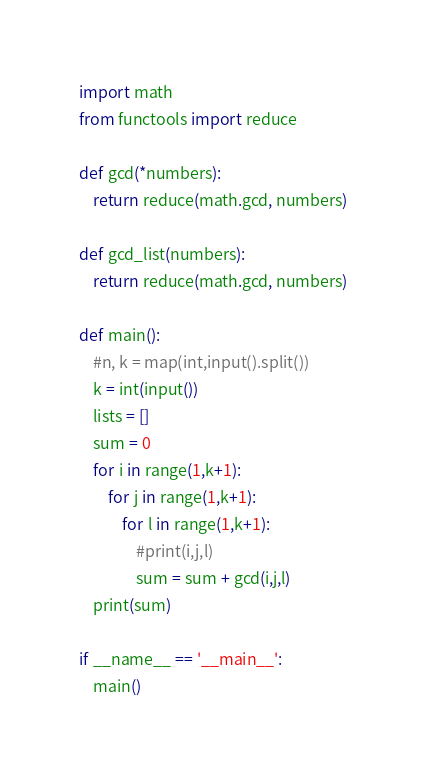<code> <loc_0><loc_0><loc_500><loc_500><_Python_>import math
from functools import reduce

def gcd(*numbers):
    return reduce(math.gcd, numbers)
  
def gcd_list(numbers):
    return reduce(math.gcd, numbers)

def main():
    #n, k = map(int,input().split())
    k = int(input())
    lists = []
    sum = 0
    for i in range(1,k+1):
        for j in range(1,k+1):
            for l in range(1,k+1):
                #print(i,j,l)
                sum = sum + gcd(i,j,l)
    print(sum)

if __name__ == '__main__':
    main()</code> 